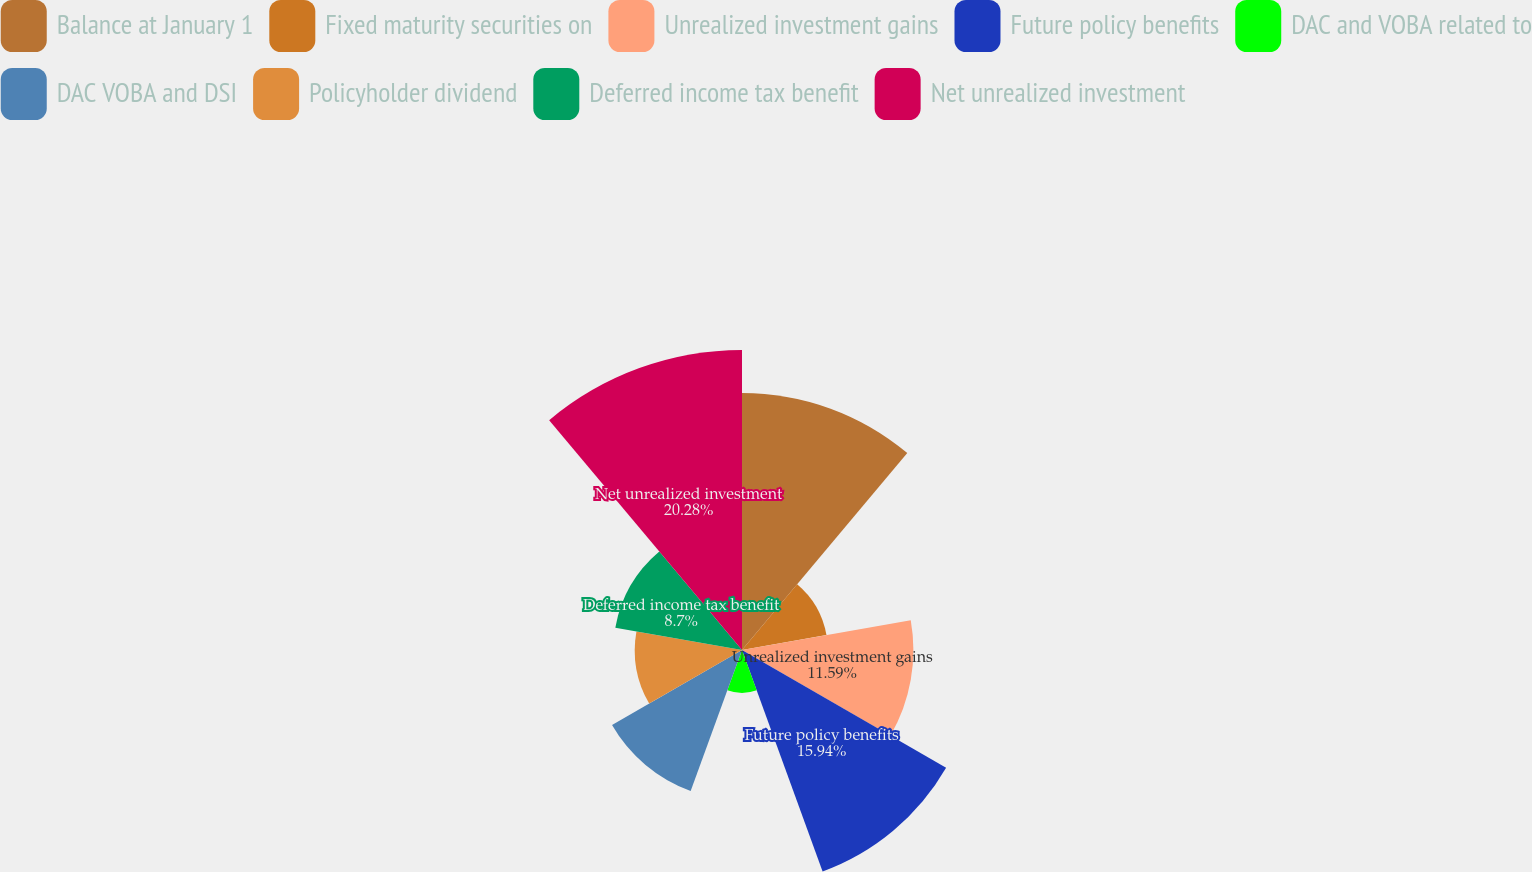Convert chart. <chart><loc_0><loc_0><loc_500><loc_500><pie_chart><fcel>Balance at January 1<fcel>Fixed maturity securities on<fcel>Unrealized investment gains<fcel>Future policy benefits<fcel>DAC and VOBA related to<fcel>DAC VOBA and DSI<fcel>Policyholder dividend<fcel>Deferred income tax benefit<fcel>Net unrealized investment<nl><fcel>17.39%<fcel>5.8%<fcel>11.59%<fcel>15.94%<fcel>2.9%<fcel>10.15%<fcel>7.25%<fcel>8.7%<fcel>20.29%<nl></chart> 